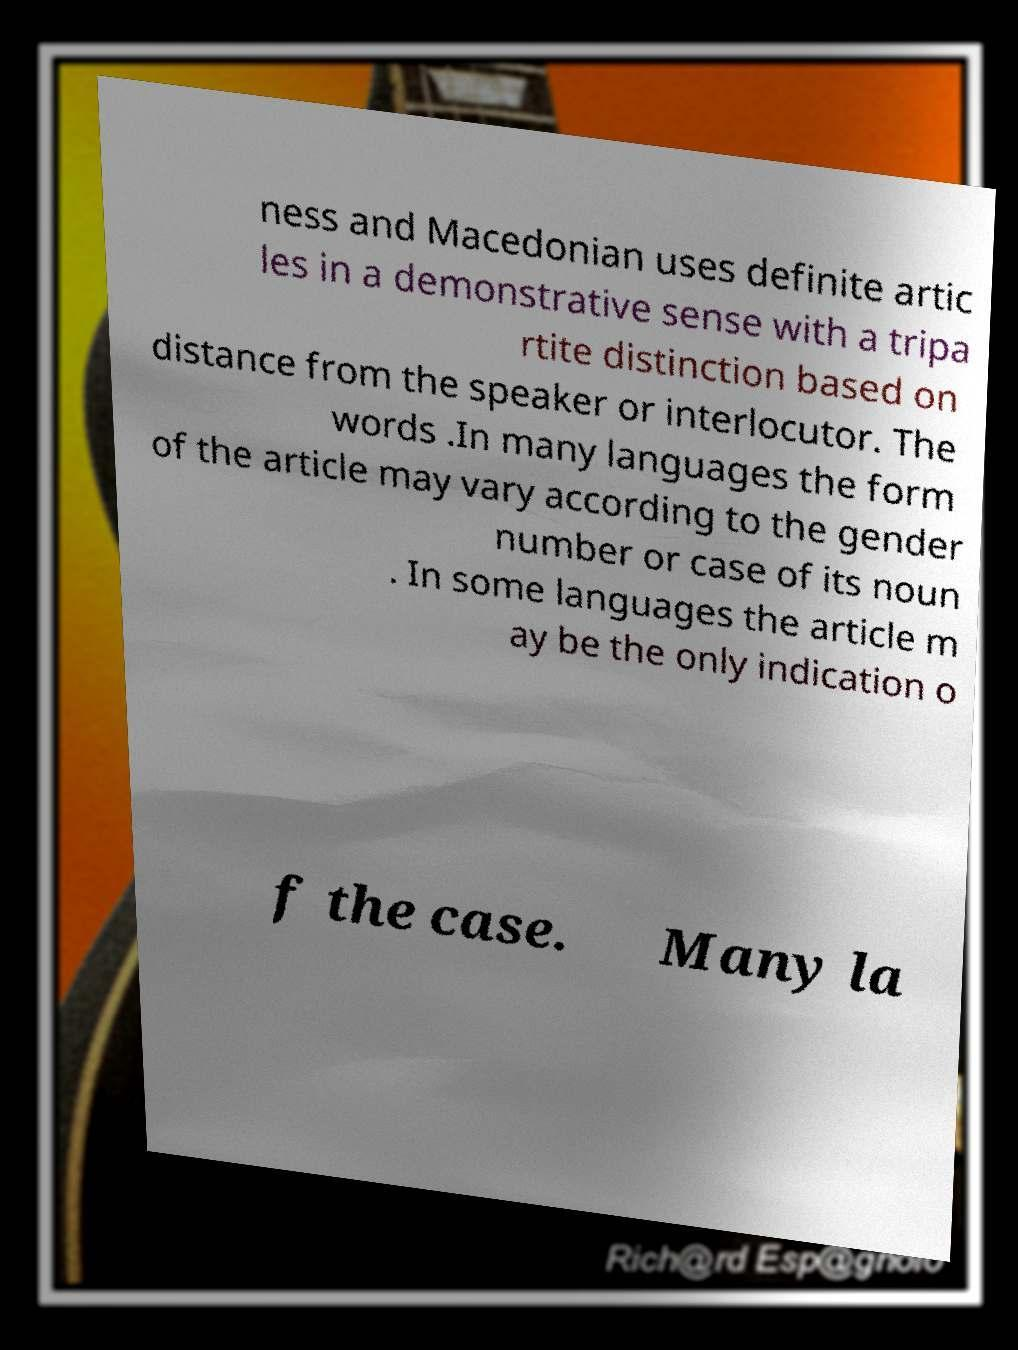Please identify and transcribe the text found in this image. ness and Macedonian uses definite artic les in a demonstrative sense with a tripa rtite distinction based on distance from the speaker or interlocutor. The words .In many languages the form of the article may vary according to the gender number or case of its noun . In some languages the article m ay be the only indication o f the case. Many la 